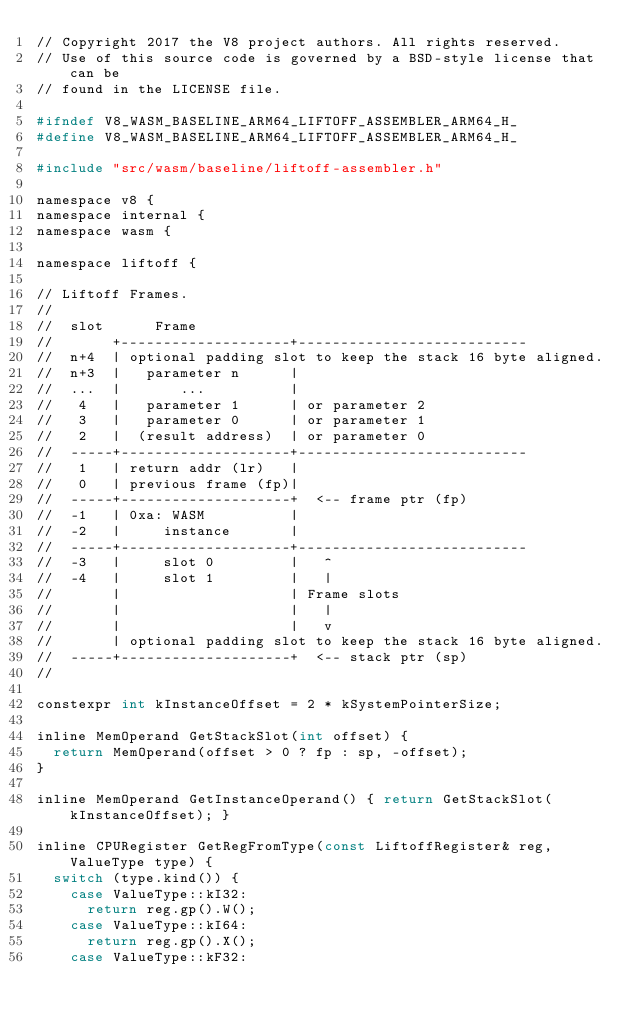Convert code to text. <code><loc_0><loc_0><loc_500><loc_500><_C_>// Copyright 2017 the V8 project authors. All rights reserved.
// Use of this source code is governed by a BSD-style license that can be
// found in the LICENSE file.

#ifndef V8_WASM_BASELINE_ARM64_LIFTOFF_ASSEMBLER_ARM64_H_
#define V8_WASM_BASELINE_ARM64_LIFTOFF_ASSEMBLER_ARM64_H_

#include "src/wasm/baseline/liftoff-assembler.h"

namespace v8 {
namespace internal {
namespace wasm {

namespace liftoff {

// Liftoff Frames.
//
//  slot      Frame
//       +--------------------+---------------------------
//  n+4  | optional padding slot to keep the stack 16 byte aligned.
//  n+3  |   parameter n      |
//  ...  |       ...          |
//   4   |   parameter 1      | or parameter 2
//   3   |   parameter 0      | or parameter 1
//   2   |  (result address)  | or parameter 0
//  -----+--------------------+---------------------------
//   1   | return addr (lr)   |
//   0   | previous frame (fp)|
//  -----+--------------------+  <-- frame ptr (fp)
//  -1   | 0xa: WASM          |
//  -2   |     instance       |
//  -----+--------------------+---------------------------
//  -3   |     slot 0         |   ^
//  -4   |     slot 1         |   |
//       |                    | Frame slots
//       |                    |   |
//       |                    |   v
//       | optional padding slot to keep the stack 16 byte aligned.
//  -----+--------------------+  <-- stack ptr (sp)
//

constexpr int kInstanceOffset = 2 * kSystemPointerSize;

inline MemOperand GetStackSlot(int offset) {
  return MemOperand(offset > 0 ? fp : sp, -offset);
}

inline MemOperand GetInstanceOperand() { return GetStackSlot(kInstanceOffset); }

inline CPURegister GetRegFromType(const LiftoffRegister& reg, ValueType type) {
  switch (type.kind()) {
    case ValueType::kI32:
      return reg.gp().W();
    case ValueType::kI64:
      return reg.gp().X();
    case ValueType::kF32:</code> 